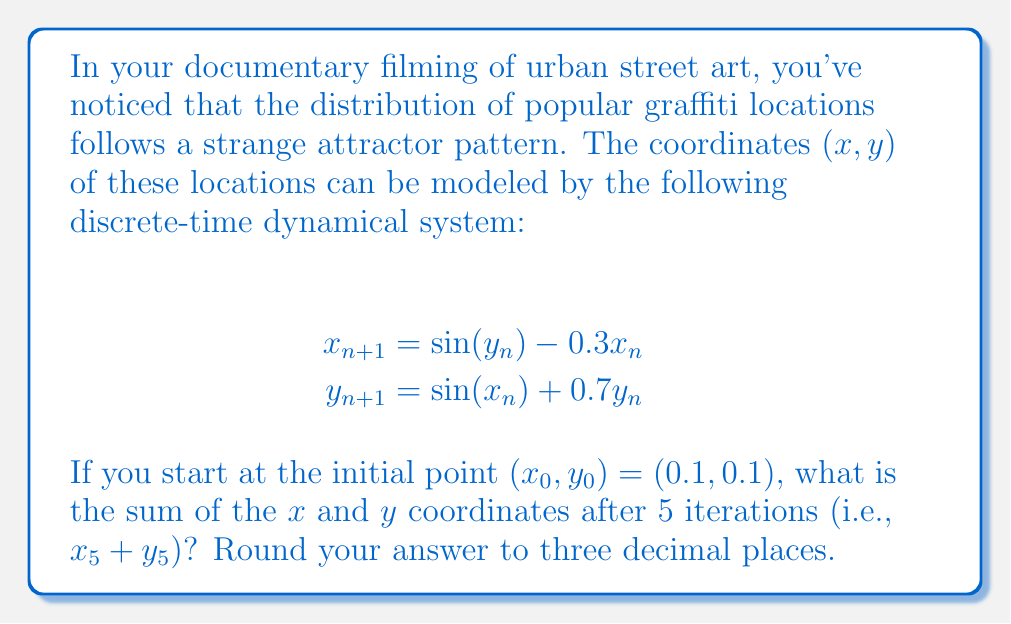Provide a solution to this math problem. To solve this problem, we need to iterate the given equations 5 times, starting from the initial point $(0.1, 0.1)$. Let's go through this step-by-step:

1) Initial point: $(x_0, y_0) = (0.1, 0.1)$

2) First iteration:
   $x_1 = \sin(0.1) - 0.3(0.1) = 0.09983 - 0.03 = 0.06983$
   $y_1 = \sin(0.1) + 0.7(0.1) = 0.09983 + 0.07 = 0.16983$

3) Second iteration:
   $x_2 = \sin(0.16983) - 0.3(0.06983) = 0.16896 - 0.02095 = 0.14801$
   $y_2 = \sin(0.06983) + 0.7(0.16983) = 0.06977 + 0.11888 = 0.18865$

4) Third iteration:
   $x_3 = \sin(0.18865) - 0.3(0.14801) = 0.18769 - 0.04440 = 0.14329$
   $y_3 = \sin(0.14801) + 0.7(0.18865) = 0.14748 + 0.13206 = 0.27954$

5) Fourth iteration:
   $x_4 = \sin(0.27954) - 0.3(0.14329) = 0.27608 - 0.04299 = 0.23309$
   $y_4 = \sin(0.14329) + 0.7(0.27954) = 0.14282 + 0.19568 = 0.33850$

6) Fifth iteration:
   $x_5 = \sin(0.33850) - 0.3(0.23309) = 0.33240 - 0.06993 = 0.26247$
   $y_5 = \sin(0.23309) + 0.7(0.33850) = 0.23112 + 0.23695 = 0.46807$

7) Sum of $x_5$ and $y_5$:
   $x_5 + y_5 = 0.26247 + 0.46807 = 0.73054$

8) Rounding to three decimal places: 0.731
Answer: 0.731 